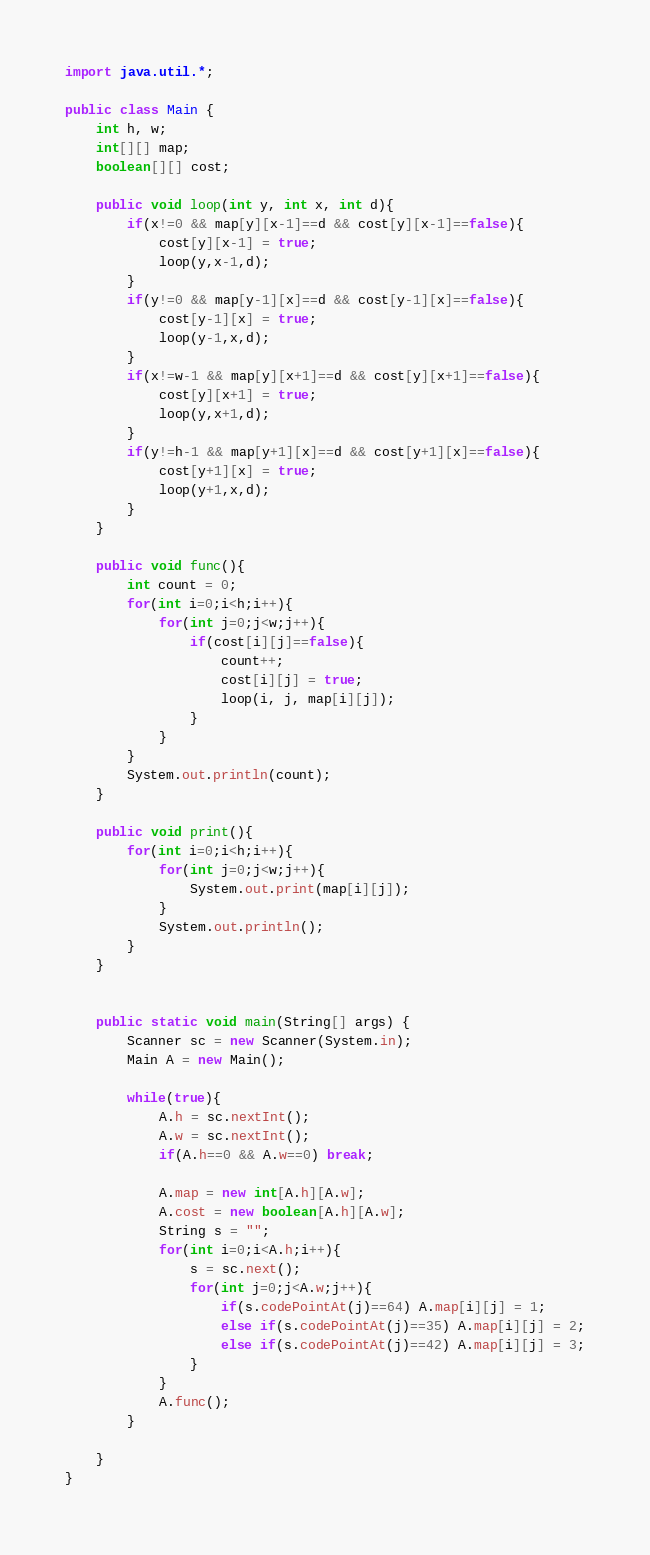<code> <loc_0><loc_0><loc_500><loc_500><_Java_>import java.util.*;

public class Main {
	int h, w;
	int[][] map;
	boolean[][] cost;
	
	public void loop(int y, int x, int d){
		if(x!=0 && map[y][x-1]==d && cost[y][x-1]==false){
			cost[y][x-1] = true;
			loop(y,x-1,d);
		}
		if(y!=0 && map[y-1][x]==d && cost[y-1][x]==false){
			cost[y-1][x] = true;
			loop(y-1,x,d);
		}
		if(x!=w-1 && map[y][x+1]==d && cost[y][x+1]==false){
			cost[y][x+1] = true;
			loop(y,x+1,d);
		}
		if(y!=h-1 && map[y+1][x]==d && cost[y+1][x]==false){
			cost[y+1][x] = true;
			loop(y+1,x,d);
		}
	}
	
	public void func(){
		int count = 0;
		for(int i=0;i<h;i++){
			for(int j=0;j<w;j++){
				if(cost[i][j]==false){
					count++;
					cost[i][j] = true;
					loop(i, j, map[i][j]);
				}
			}
		}
		System.out.println(count);
	}
	
	public void print(){
		for(int i=0;i<h;i++){
			for(int j=0;j<w;j++){
				System.out.print(map[i][j]);
			}
			System.out.println();
		}
	}
	
	
	public static void main(String[] args) {
		Scanner sc = new Scanner(System.in);
		Main A = new Main();
		
		while(true){
			A.h = sc.nextInt();
			A.w = sc.nextInt();
			if(A.h==0 && A.w==0) break;
			
			A.map = new int[A.h][A.w];
			A.cost = new boolean[A.h][A.w];
			String s = "";
			for(int i=0;i<A.h;i++){
				s = sc.next();
				for(int j=0;j<A.w;j++){
					if(s.codePointAt(j)==64) A.map[i][j] = 1;
					else if(s.codePointAt(j)==35) A.map[i][j] = 2;
					else if(s.codePointAt(j)==42) A.map[i][j] = 3;
				}
			}
			A.func();
		}
		
	}	
}</code> 